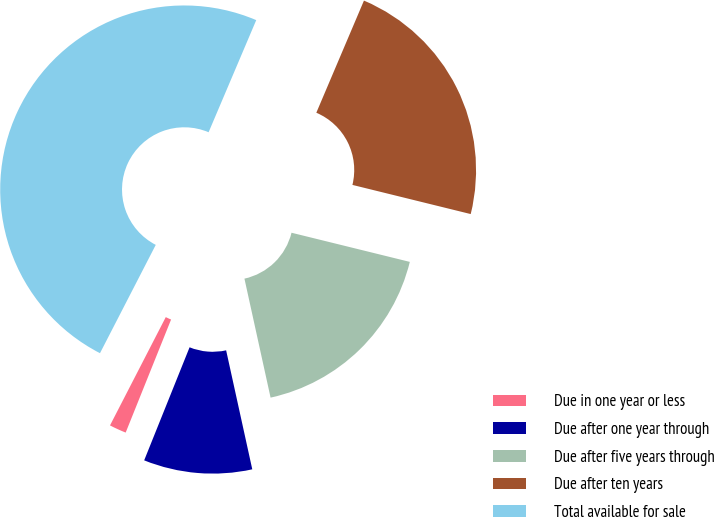<chart> <loc_0><loc_0><loc_500><loc_500><pie_chart><fcel>Due in one year or less<fcel>Due after one year through<fcel>Due after five years through<fcel>Due after ten years<fcel>Total available for sale<nl><fcel>1.49%<fcel>9.52%<fcel>17.71%<fcel>22.45%<fcel>48.82%<nl></chart> 